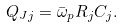<formula> <loc_0><loc_0><loc_500><loc_500>Q _ { J j } = \bar { \omega } _ { p } R _ { j } C _ { j } .</formula> 